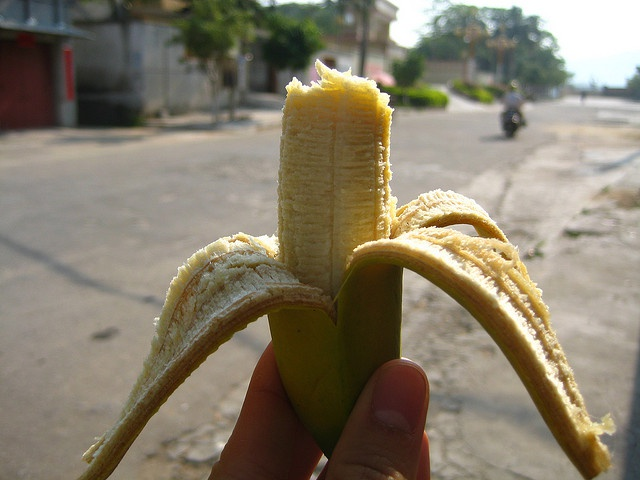Describe the objects in this image and their specific colors. I can see banana in black, olive, maroon, and gray tones, people in black, maroon, and gray tones, motorcycle in black, gray, and darkblue tones, and people in black and gray tones in this image. 